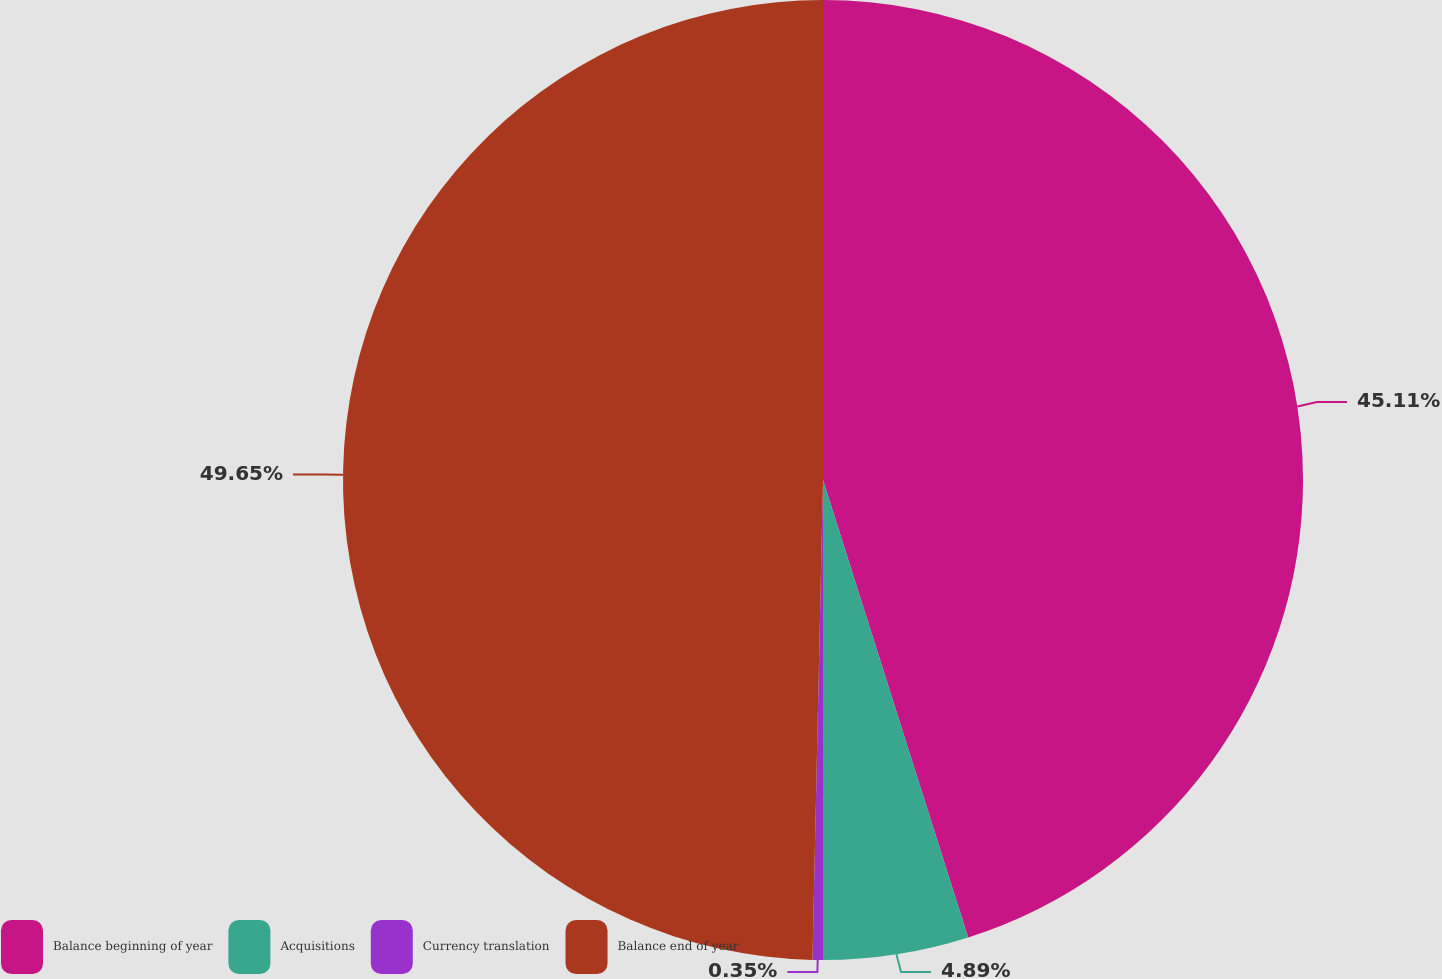Convert chart to OTSL. <chart><loc_0><loc_0><loc_500><loc_500><pie_chart><fcel>Balance beginning of year<fcel>Acquisitions<fcel>Currency translation<fcel>Balance end of year<nl><fcel>45.11%<fcel>4.89%<fcel>0.35%<fcel>49.65%<nl></chart> 